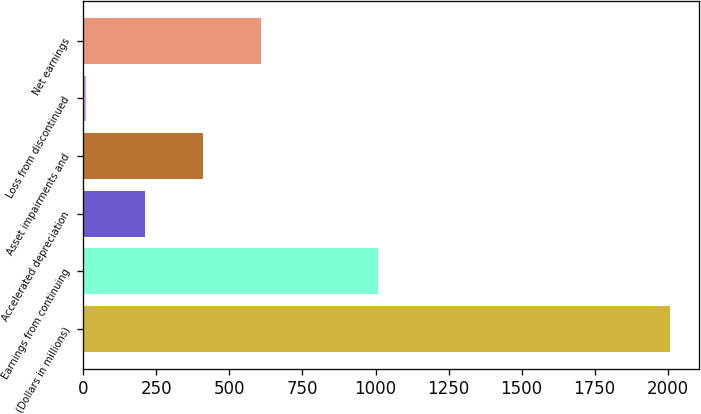Convert chart. <chart><loc_0><loc_0><loc_500><loc_500><bar_chart><fcel>(Dollars in millions)<fcel>Earnings from continuing<fcel>Accelerated depreciation<fcel>Asset impairments and<fcel>Loss from discontinued<fcel>Net earnings<nl><fcel>2007<fcel>1008.5<fcel>209.7<fcel>409.4<fcel>10<fcel>609.1<nl></chart> 